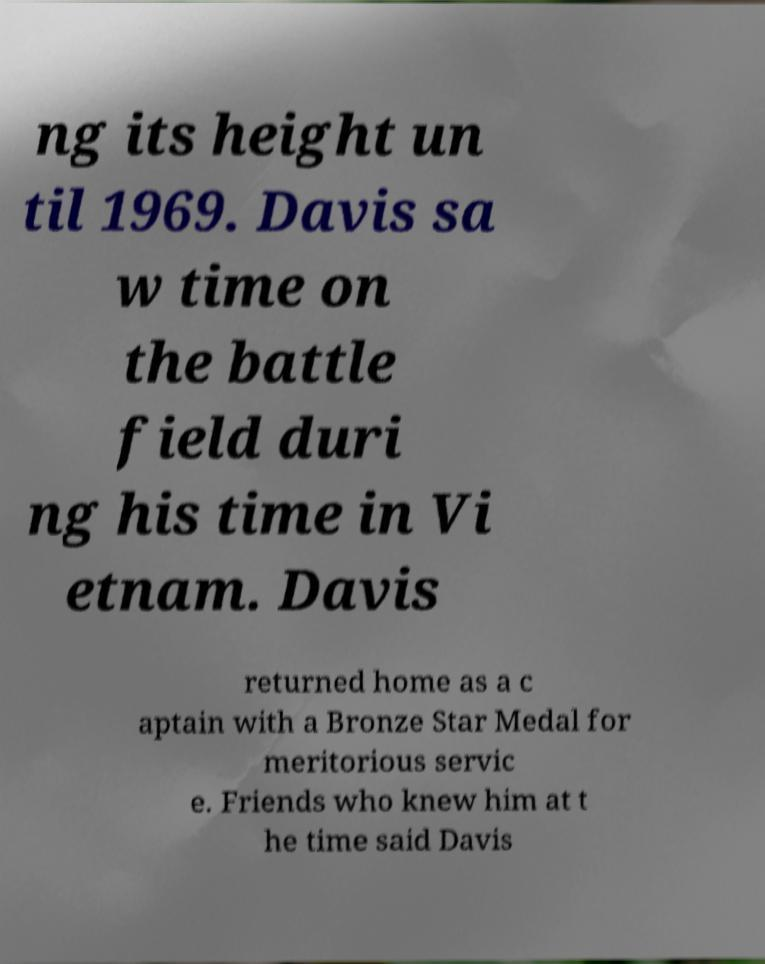For documentation purposes, I need the text within this image transcribed. Could you provide that? ng its height un til 1969. Davis sa w time on the battle field duri ng his time in Vi etnam. Davis returned home as a c aptain with a Bronze Star Medal for meritorious servic e. Friends who knew him at t he time said Davis 